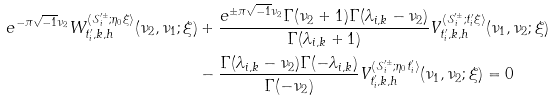Convert formula to latex. <formula><loc_0><loc_0><loc_500><loc_500>e ^ { - \pi \sqrt { - 1 } \nu _ { 2 } } W ^ { \langle \mathcal { S } ^ { \prime \pm } _ { i } ; \eta _ { 0 } \xi \rangle } _ { t ^ { \prime } _ { i } , k , h } ( \nu _ { 2 } , \nu _ { 1 } ; \xi ) & + \frac { e ^ { \pm \pi \sqrt { - 1 } \nu _ { 2 } } \Gamma ( \nu _ { 2 } + 1 ) \Gamma ( \lambda _ { i , k } - \nu _ { 2 } ) } { \Gamma ( \lambda _ { i , k } + 1 ) } V ^ { \langle \mathcal { S } ^ { \prime \pm } _ { i } ; t ^ { \prime } _ { i } \xi \rangle } _ { t ^ { \prime } _ { i } , k , h } ( \nu _ { 1 } , \nu _ { 2 } ; \xi ) \\ & - \frac { \Gamma ( \lambda _ { i , k } - \nu _ { 2 } ) \Gamma ( - \lambda _ { i , k } ) } { \Gamma ( - \nu _ { 2 } ) } V ^ { \langle \mathcal { S } ^ { \prime \pm } _ { i } ; \eta _ { 0 } t ^ { \prime } _ { i } \rangle } _ { t ^ { \prime } _ { i } , k , h } ( \nu _ { 1 } , \nu _ { 2 } ; \xi ) = 0</formula> 